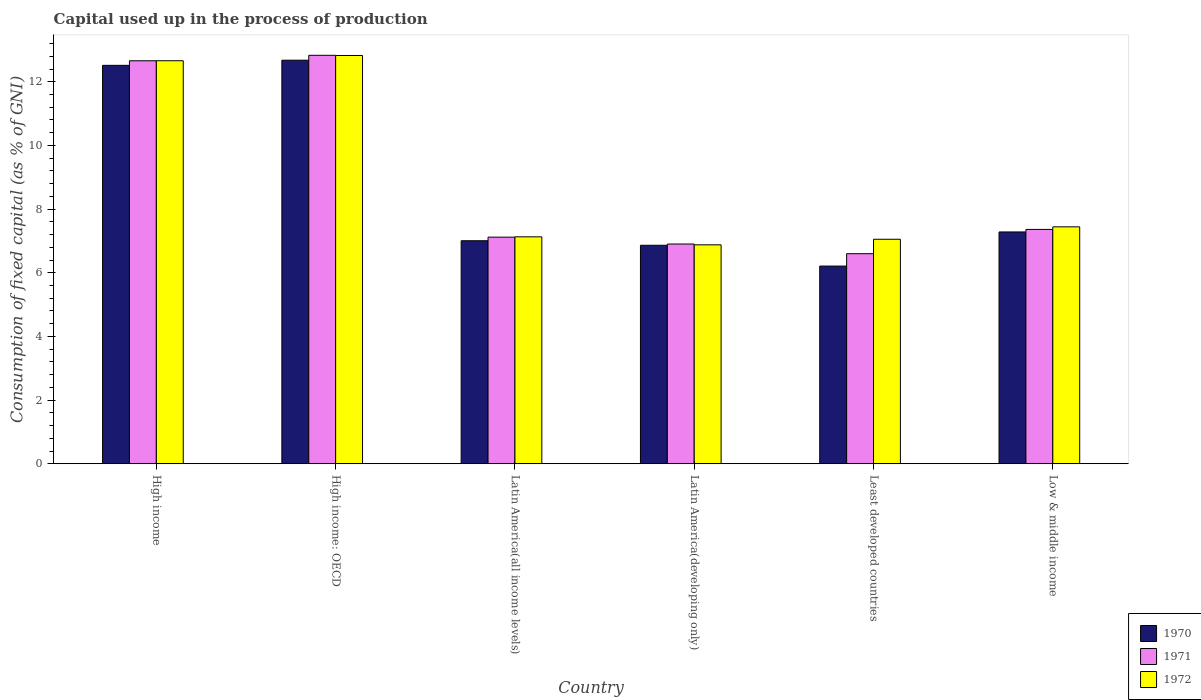How many groups of bars are there?
Keep it short and to the point. 6. Are the number of bars per tick equal to the number of legend labels?
Give a very brief answer. Yes. How many bars are there on the 2nd tick from the right?
Keep it short and to the point. 3. What is the label of the 1st group of bars from the left?
Provide a succinct answer. High income. In how many cases, is the number of bars for a given country not equal to the number of legend labels?
Your answer should be very brief. 0. What is the capital used up in the process of production in 1970 in High income?
Your response must be concise. 12.52. Across all countries, what is the maximum capital used up in the process of production in 1970?
Give a very brief answer. 12.68. Across all countries, what is the minimum capital used up in the process of production in 1970?
Ensure brevity in your answer.  6.21. In which country was the capital used up in the process of production in 1971 maximum?
Ensure brevity in your answer.  High income: OECD. In which country was the capital used up in the process of production in 1971 minimum?
Your answer should be very brief. Least developed countries. What is the total capital used up in the process of production in 1970 in the graph?
Your response must be concise. 52.56. What is the difference between the capital used up in the process of production in 1971 in Latin America(developing only) and that in Least developed countries?
Give a very brief answer. 0.3. What is the difference between the capital used up in the process of production in 1970 in Low & middle income and the capital used up in the process of production in 1972 in High income?
Your answer should be very brief. -5.38. What is the average capital used up in the process of production in 1970 per country?
Your response must be concise. 8.76. What is the difference between the capital used up in the process of production of/in 1971 and capital used up in the process of production of/in 1972 in Latin America(developing only)?
Your response must be concise. 0.03. What is the ratio of the capital used up in the process of production in 1972 in High income: OECD to that in Least developed countries?
Your response must be concise. 1.82. Is the capital used up in the process of production in 1972 in High income: OECD less than that in Least developed countries?
Offer a very short reply. No. Is the difference between the capital used up in the process of production in 1971 in High income and Latin America(all income levels) greater than the difference between the capital used up in the process of production in 1972 in High income and Latin America(all income levels)?
Provide a short and direct response. Yes. What is the difference between the highest and the second highest capital used up in the process of production in 1970?
Ensure brevity in your answer.  0.16. What is the difference between the highest and the lowest capital used up in the process of production in 1972?
Offer a terse response. 5.95. In how many countries, is the capital used up in the process of production in 1970 greater than the average capital used up in the process of production in 1970 taken over all countries?
Your answer should be compact. 2. What does the 1st bar from the left in High income represents?
Your answer should be compact. 1970. Are all the bars in the graph horizontal?
Provide a short and direct response. No. How many countries are there in the graph?
Your answer should be compact. 6. What is the difference between two consecutive major ticks on the Y-axis?
Your answer should be compact. 2. How many legend labels are there?
Offer a very short reply. 3. How are the legend labels stacked?
Your answer should be very brief. Vertical. What is the title of the graph?
Offer a terse response. Capital used up in the process of production. Does "1964" appear as one of the legend labels in the graph?
Ensure brevity in your answer.  No. What is the label or title of the Y-axis?
Make the answer very short. Consumption of fixed capital (as % of GNI). What is the Consumption of fixed capital (as % of GNI) of 1970 in High income?
Provide a succinct answer. 12.52. What is the Consumption of fixed capital (as % of GNI) of 1971 in High income?
Offer a very short reply. 12.66. What is the Consumption of fixed capital (as % of GNI) in 1972 in High income?
Provide a short and direct response. 12.66. What is the Consumption of fixed capital (as % of GNI) of 1970 in High income: OECD?
Keep it short and to the point. 12.68. What is the Consumption of fixed capital (as % of GNI) of 1971 in High income: OECD?
Offer a very short reply. 12.83. What is the Consumption of fixed capital (as % of GNI) in 1972 in High income: OECD?
Provide a short and direct response. 12.83. What is the Consumption of fixed capital (as % of GNI) of 1970 in Latin America(all income levels)?
Ensure brevity in your answer.  7.01. What is the Consumption of fixed capital (as % of GNI) of 1971 in Latin America(all income levels)?
Your answer should be compact. 7.12. What is the Consumption of fixed capital (as % of GNI) in 1972 in Latin America(all income levels)?
Offer a very short reply. 7.13. What is the Consumption of fixed capital (as % of GNI) in 1970 in Latin America(developing only)?
Provide a succinct answer. 6.86. What is the Consumption of fixed capital (as % of GNI) of 1971 in Latin America(developing only)?
Your answer should be compact. 6.9. What is the Consumption of fixed capital (as % of GNI) of 1972 in Latin America(developing only)?
Offer a terse response. 6.88. What is the Consumption of fixed capital (as % of GNI) of 1970 in Least developed countries?
Make the answer very short. 6.21. What is the Consumption of fixed capital (as % of GNI) of 1971 in Least developed countries?
Keep it short and to the point. 6.6. What is the Consumption of fixed capital (as % of GNI) in 1972 in Least developed countries?
Ensure brevity in your answer.  7.05. What is the Consumption of fixed capital (as % of GNI) in 1970 in Low & middle income?
Offer a very short reply. 7.28. What is the Consumption of fixed capital (as % of GNI) in 1971 in Low & middle income?
Your answer should be compact. 7.36. What is the Consumption of fixed capital (as % of GNI) in 1972 in Low & middle income?
Provide a succinct answer. 7.44. Across all countries, what is the maximum Consumption of fixed capital (as % of GNI) of 1970?
Offer a terse response. 12.68. Across all countries, what is the maximum Consumption of fixed capital (as % of GNI) in 1971?
Offer a terse response. 12.83. Across all countries, what is the maximum Consumption of fixed capital (as % of GNI) of 1972?
Make the answer very short. 12.83. Across all countries, what is the minimum Consumption of fixed capital (as % of GNI) of 1970?
Your answer should be compact. 6.21. Across all countries, what is the minimum Consumption of fixed capital (as % of GNI) of 1971?
Offer a very short reply. 6.6. Across all countries, what is the minimum Consumption of fixed capital (as % of GNI) in 1972?
Make the answer very short. 6.88. What is the total Consumption of fixed capital (as % of GNI) in 1970 in the graph?
Offer a terse response. 52.56. What is the total Consumption of fixed capital (as % of GNI) in 1971 in the graph?
Make the answer very short. 53.47. What is the total Consumption of fixed capital (as % of GNI) in 1972 in the graph?
Offer a very short reply. 53.99. What is the difference between the Consumption of fixed capital (as % of GNI) of 1970 in High income and that in High income: OECD?
Offer a very short reply. -0.16. What is the difference between the Consumption of fixed capital (as % of GNI) in 1971 in High income and that in High income: OECD?
Your answer should be compact. -0.17. What is the difference between the Consumption of fixed capital (as % of GNI) of 1972 in High income and that in High income: OECD?
Provide a succinct answer. -0.17. What is the difference between the Consumption of fixed capital (as % of GNI) of 1970 in High income and that in Latin America(all income levels)?
Your answer should be very brief. 5.51. What is the difference between the Consumption of fixed capital (as % of GNI) in 1971 in High income and that in Latin America(all income levels)?
Make the answer very short. 5.54. What is the difference between the Consumption of fixed capital (as % of GNI) of 1972 in High income and that in Latin America(all income levels)?
Ensure brevity in your answer.  5.53. What is the difference between the Consumption of fixed capital (as % of GNI) in 1970 in High income and that in Latin America(developing only)?
Your answer should be very brief. 5.65. What is the difference between the Consumption of fixed capital (as % of GNI) of 1971 in High income and that in Latin America(developing only)?
Keep it short and to the point. 5.76. What is the difference between the Consumption of fixed capital (as % of GNI) of 1972 in High income and that in Latin America(developing only)?
Your answer should be very brief. 5.78. What is the difference between the Consumption of fixed capital (as % of GNI) in 1970 in High income and that in Least developed countries?
Give a very brief answer. 6.31. What is the difference between the Consumption of fixed capital (as % of GNI) in 1971 in High income and that in Least developed countries?
Offer a terse response. 6.06. What is the difference between the Consumption of fixed capital (as % of GNI) in 1972 in High income and that in Least developed countries?
Give a very brief answer. 5.61. What is the difference between the Consumption of fixed capital (as % of GNI) of 1970 in High income and that in Low & middle income?
Make the answer very short. 5.23. What is the difference between the Consumption of fixed capital (as % of GNI) of 1971 in High income and that in Low & middle income?
Offer a terse response. 5.3. What is the difference between the Consumption of fixed capital (as % of GNI) of 1972 in High income and that in Low & middle income?
Your response must be concise. 5.22. What is the difference between the Consumption of fixed capital (as % of GNI) in 1970 in High income: OECD and that in Latin America(all income levels)?
Your answer should be compact. 5.67. What is the difference between the Consumption of fixed capital (as % of GNI) in 1971 in High income: OECD and that in Latin America(all income levels)?
Your answer should be very brief. 5.71. What is the difference between the Consumption of fixed capital (as % of GNI) in 1972 in High income: OECD and that in Latin America(all income levels)?
Your answer should be compact. 5.7. What is the difference between the Consumption of fixed capital (as % of GNI) of 1970 in High income: OECD and that in Latin America(developing only)?
Offer a very short reply. 5.81. What is the difference between the Consumption of fixed capital (as % of GNI) of 1971 in High income: OECD and that in Latin America(developing only)?
Make the answer very short. 5.93. What is the difference between the Consumption of fixed capital (as % of GNI) of 1972 in High income: OECD and that in Latin America(developing only)?
Your response must be concise. 5.95. What is the difference between the Consumption of fixed capital (as % of GNI) in 1970 in High income: OECD and that in Least developed countries?
Provide a short and direct response. 6.47. What is the difference between the Consumption of fixed capital (as % of GNI) in 1971 in High income: OECD and that in Least developed countries?
Your answer should be very brief. 6.23. What is the difference between the Consumption of fixed capital (as % of GNI) of 1972 in High income: OECD and that in Least developed countries?
Your answer should be compact. 5.77. What is the difference between the Consumption of fixed capital (as % of GNI) of 1970 in High income: OECD and that in Low & middle income?
Offer a very short reply. 5.4. What is the difference between the Consumption of fixed capital (as % of GNI) in 1971 in High income: OECD and that in Low & middle income?
Provide a short and direct response. 5.47. What is the difference between the Consumption of fixed capital (as % of GNI) of 1972 in High income: OECD and that in Low & middle income?
Your response must be concise. 5.38. What is the difference between the Consumption of fixed capital (as % of GNI) in 1970 in Latin America(all income levels) and that in Latin America(developing only)?
Your answer should be very brief. 0.14. What is the difference between the Consumption of fixed capital (as % of GNI) in 1971 in Latin America(all income levels) and that in Latin America(developing only)?
Provide a succinct answer. 0.22. What is the difference between the Consumption of fixed capital (as % of GNI) in 1972 in Latin America(all income levels) and that in Latin America(developing only)?
Your answer should be very brief. 0.25. What is the difference between the Consumption of fixed capital (as % of GNI) of 1970 in Latin America(all income levels) and that in Least developed countries?
Give a very brief answer. 0.8. What is the difference between the Consumption of fixed capital (as % of GNI) of 1971 in Latin America(all income levels) and that in Least developed countries?
Your answer should be very brief. 0.52. What is the difference between the Consumption of fixed capital (as % of GNI) in 1972 in Latin America(all income levels) and that in Least developed countries?
Your answer should be compact. 0.08. What is the difference between the Consumption of fixed capital (as % of GNI) in 1970 in Latin America(all income levels) and that in Low & middle income?
Provide a short and direct response. -0.28. What is the difference between the Consumption of fixed capital (as % of GNI) in 1971 in Latin America(all income levels) and that in Low & middle income?
Offer a terse response. -0.24. What is the difference between the Consumption of fixed capital (as % of GNI) in 1972 in Latin America(all income levels) and that in Low & middle income?
Offer a very short reply. -0.31. What is the difference between the Consumption of fixed capital (as % of GNI) in 1970 in Latin America(developing only) and that in Least developed countries?
Provide a short and direct response. 0.65. What is the difference between the Consumption of fixed capital (as % of GNI) in 1971 in Latin America(developing only) and that in Least developed countries?
Give a very brief answer. 0.3. What is the difference between the Consumption of fixed capital (as % of GNI) in 1972 in Latin America(developing only) and that in Least developed countries?
Ensure brevity in your answer.  -0.18. What is the difference between the Consumption of fixed capital (as % of GNI) of 1970 in Latin America(developing only) and that in Low & middle income?
Offer a very short reply. -0.42. What is the difference between the Consumption of fixed capital (as % of GNI) of 1971 in Latin America(developing only) and that in Low & middle income?
Give a very brief answer. -0.46. What is the difference between the Consumption of fixed capital (as % of GNI) in 1972 in Latin America(developing only) and that in Low & middle income?
Ensure brevity in your answer.  -0.57. What is the difference between the Consumption of fixed capital (as % of GNI) in 1970 in Least developed countries and that in Low & middle income?
Keep it short and to the point. -1.07. What is the difference between the Consumption of fixed capital (as % of GNI) in 1971 in Least developed countries and that in Low & middle income?
Keep it short and to the point. -0.76. What is the difference between the Consumption of fixed capital (as % of GNI) of 1972 in Least developed countries and that in Low & middle income?
Keep it short and to the point. -0.39. What is the difference between the Consumption of fixed capital (as % of GNI) of 1970 in High income and the Consumption of fixed capital (as % of GNI) of 1971 in High income: OECD?
Your response must be concise. -0.32. What is the difference between the Consumption of fixed capital (as % of GNI) of 1970 in High income and the Consumption of fixed capital (as % of GNI) of 1972 in High income: OECD?
Make the answer very short. -0.31. What is the difference between the Consumption of fixed capital (as % of GNI) in 1971 in High income and the Consumption of fixed capital (as % of GNI) in 1972 in High income: OECD?
Give a very brief answer. -0.17. What is the difference between the Consumption of fixed capital (as % of GNI) of 1970 in High income and the Consumption of fixed capital (as % of GNI) of 1971 in Latin America(all income levels)?
Keep it short and to the point. 5.4. What is the difference between the Consumption of fixed capital (as % of GNI) of 1970 in High income and the Consumption of fixed capital (as % of GNI) of 1972 in Latin America(all income levels)?
Your answer should be compact. 5.39. What is the difference between the Consumption of fixed capital (as % of GNI) in 1971 in High income and the Consumption of fixed capital (as % of GNI) in 1972 in Latin America(all income levels)?
Your response must be concise. 5.53. What is the difference between the Consumption of fixed capital (as % of GNI) in 1970 in High income and the Consumption of fixed capital (as % of GNI) in 1971 in Latin America(developing only)?
Make the answer very short. 5.61. What is the difference between the Consumption of fixed capital (as % of GNI) in 1970 in High income and the Consumption of fixed capital (as % of GNI) in 1972 in Latin America(developing only)?
Provide a short and direct response. 5.64. What is the difference between the Consumption of fixed capital (as % of GNI) of 1971 in High income and the Consumption of fixed capital (as % of GNI) of 1972 in Latin America(developing only)?
Provide a succinct answer. 5.78. What is the difference between the Consumption of fixed capital (as % of GNI) in 1970 in High income and the Consumption of fixed capital (as % of GNI) in 1971 in Least developed countries?
Provide a short and direct response. 5.92. What is the difference between the Consumption of fixed capital (as % of GNI) in 1970 in High income and the Consumption of fixed capital (as % of GNI) in 1972 in Least developed countries?
Your answer should be compact. 5.46. What is the difference between the Consumption of fixed capital (as % of GNI) of 1971 in High income and the Consumption of fixed capital (as % of GNI) of 1972 in Least developed countries?
Provide a short and direct response. 5.61. What is the difference between the Consumption of fixed capital (as % of GNI) in 1970 in High income and the Consumption of fixed capital (as % of GNI) in 1971 in Low & middle income?
Your answer should be very brief. 5.15. What is the difference between the Consumption of fixed capital (as % of GNI) of 1970 in High income and the Consumption of fixed capital (as % of GNI) of 1972 in Low & middle income?
Your response must be concise. 5.07. What is the difference between the Consumption of fixed capital (as % of GNI) in 1971 in High income and the Consumption of fixed capital (as % of GNI) in 1972 in Low & middle income?
Make the answer very short. 5.22. What is the difference between the Consumption of fixed capital (as % of GNI) in 1970 in High income: OECD and the Consumption of fixed capital (as % of GNI) in 1971 in Latin America(all income levels)?
Keep it short and to the point. 5.56. What is the difference between the Consumption of fixed capital (as % of GNI) of 1970 in High income: OECD and the Consumption of fixed capital (as % of GNI) of 1972 in Latin America(all income levels)?
Give a very brief answer. 5.55. What is the difference between the Consumption of fixed capital (as % of GNI) in 1971 in High income: OECD and the Consumption of fixed capital (as % of GNI) in 1972 in Latin America(all income levels)?
Offer a very short reply. 5.7. What is the difference between the Consumption of fixed capital (as % of GNI) in 1970 in High income: OECD and the Consumption of fixed capital (as % of GNI) in 1971 in Latin America(developing only)?
Ensure brevity in your answer.  5.78. What is the difference between the Consumption of fixed capital (as % of GNI) of 1970 in High income: OECD and the Consumption of fixed capital (as % of GNI) of 1972 in Latin America(developing only)?
Your answer should be very brief. 5.8. What is the difference between the Consumption of fixed capital (as % of GNI) of 1971 in High income: OECD and the Consumption of fixed capital (as % of GNI) of 1972 in Latin America(developing only)?
Your answer should be very brief. 5.95. What is the difference between the Consumption of fixed capital (as % of GNI) of 1970 in High income: OECD and the Consumption of fixed capital (as % of GNI) of 1971 in Least developed countries?
Offer a terse response. 6.08. What is the difference between the Consumption of fixed capital (as % of GNI) in 1970 in High income: OECD and the Consumption of fixed capital (as % of GNI) in 1972 in Least developed countries?
Provide a succinct answer. 5.63. What is the difference between the Consumption of fixed capital (as % of GNI) in 1971 in High income: OECD and the Consumption of fixed capital (as % of GNI) in 1972 in Least developed countries?
Offer a very short reply. 5.78. What is the difference between the Consumption of fixed capital (as % of GNI) in 1970 in High income: OECD and the Consumption of fixed capital (as % of GNI) in 1971 in Low & middle income?
Give a very brief answer. 5.32. What is the difference between the Consumption of fixed capital (as % of GNI) in 1970 in High income: OECD and the Consumption of fixed capital (as % of GNI) in 1972 in Low & middle income?
Make the answer very short. 5.24. What is the difference between the Consumption of fixed capital (as % of GNI) in 1971 in High income: OECD and the Consumption of fixed capital (as % of GNI) in 1972 in Low & middle income?
Provide a short and direct response. 5.39. What is the difference between the Consumption of fixed capital (as % of GNI) of 1970 in Latin America(all income levels) and the Consumption of fixed capital (as % of GNI) of 1971 in Latin America(developing only)?
Your answer should be compact. 0.1. What is the difference between the Consumption of fixed capital (as % of GNI) of 1970 in Latin America(all income levels) and the Consumption of fixed capital (as % of GNI) of 1972 in Latin America(developing only)?
Offer a very short reply. 0.13. What is the difference between the Consumption of fixed capital (as % of GNI) of 1971 in Latin America(all income levels) and the Consumption of fixed capital (as % of GNI) of 1972 in Latin America(developing only)?
Provide a short and direct response. 0.24. What is the difference between the Consumption of fixed capital (as % of GNI) of 1970 in Latin America(all income levels) and the Consumption of fixed capital (as % of GNI) of 1971 in Least developed countries?
Your response must be concise. 0.41. What is the difference between the Consumption of fixed capital (as % of GNI) of 1970 in Latin America(all income levels) and the Consumption of fixed capital (as % of GNI) of 1972 in Least developed countries?
Your answer should be very brief. -0.05. What is the difference between the Consumption of fixed capital (as % of GNI) of 1971 in Latin America(all income levels) and the Consumption of fixed capital (as % of GNI) of 1972 in Least developed countries?
Offer a terse response. 0.07. What is the difference between the Consumption of fixed capital (as % of GNI) of 1970 in Latin America(all income levels) and the Consumption of fixed capital (as % of GNI) of 1971 in Low & middle income?
Provide a succinct answer. -0.36. What is the difference between the Consumption of fixed capital (as % of GNI) of 1970 in Latin America(all income levels) and the Consumption of fixed capital (as % of GNI) of 1972 in Low & middle income?
Your response must be concise. -0.44. What is the difference between the Consumption of fixed capital (as % of GNI) in 1971 in Latin America(all income levels) and the Consumption of fixed capital (as % of GNI) in 1972 in Low & middle income?
Offer a very short reply. -0.32. What is the difference between the Consumption of fixed capital (as % of GNI) in 1970 in Latin America(developing only) and the Consumption of fixed capital (as % of GNI) in 1971 in Least developed countries?
Your answer should be compact. 0.26. What is the difference between the Consumption of fixed capital (as % of GNI) in 1970 in Latin America(developing only) and the Consumption of fixed capital (as % of GNI) in 1972 in Least developed countries?
Your answer should be very brief. -0.19. What is the difference between the Consumption of fixed capital (as % of GNI) of 1971 in Latin America(developing only) and the Consumption of fixed capital (as % of GNI) of 1972 in Least developed countries?
Your answer should be compact. -0.15. What is the difference between the Consumption of fixed capital (as % of GNI) of 1970 in Latin America(developing only) and the Consumption of fixed capital (as % of GNI) of 1971 in Low & middle income?
Ensure brevity in your answer.  -0.5. What is the difference between the Consumption of fixed capital (as % of GNI) of 1970 in Latin America(developing only) and the Consumption of fixed capital (as % of GNI) of 1972 in Low & middle income?
Offer a very short reply. -0.58. What is the difference between the Consumption of fixed capital (as % of GNI) of 1971 in Latin America(developing only) and the Consumption of fixed capital (as % of GNI) of 1972 in Low & middle income?
Offer a terse response. -0.54. What is the difference between the Consumption of fixed capital (as % of GNI) of 1970 in Least developed countries and the Consumption of fixed capital (as % of GNI) of 1971 in Low & middle income?
Offer a terse response. -1.15. What is the difference between the Consumption of fixed capital (as % of GNI) of 1970 in Least developed countries and the Consumption of fixed capital (as % of GNI) of 1972 in Low & middle income?
Ensure brevity in your answer.  -1.23. What is the difference between the Consumption of fixed capital (as % of GNI) in 1971 in Least developed countries and the Consumption of fixed capital (as % of GNI) in 1972 in Low & middle income?
Your response must be concise. -0.84. What is the average Consumption of fixed capital (as % of GNI) in 1970 per country?
Your answer should be very brief. 8.76. What is the average Consumption of fixed capital (as % of GNI) in 1971 per country?
Offer a terse response. 8.91. What is the average Consumption of fixed capital (as % of GNI) of 1972 per country?
Ensure brevity in your answer.  9. What is the difference between the Consumption of fixed capital (as % of GNI) of 1970 and Consumption of fixed capital (as % of GNI) of 1971 in High income?
Provide a short and direct response. -0.14. What is the difference between the Consumption of fixed capital (as % of GNI) in 1970 and Consumption of fixed capital (as % of GNI) in 1972 in High income?
Your answer should be compact. -0.14. What is the difference between the Consumption of fixed capital (as % of GNI) in 1971 and Consumption of fixed capital (as % of GNI) in 1972 in High income?
Keep it short and to the point. -0. What is the difference between the Consumption of fixed capital (as % of GNI) of 1970 and Consumption of fixed capital (as % of GNI) of 1971 in High income: OECD?
Ensure brevity in your answer.  -0.15. What is the difference between the Consumption of fixed capital (as % of GNI) of 1970 and Consumption of fixed capital (as % of GNI) of 1972 in High income: OECD?
Provide a succinct answer. -0.15. What is the difference between the Consumption of fixed capital (as % of GNI) in 1971 and Consumption of fixed capital (as % of GNI) in 1972 in High income: OECD?
Keep it short and to the point. 0.01. What is the difference between the Consumption of fixed capital (as % of GNI) in 1970 and Consumption of fixed capital (as % of GNI) in 1971 in Latin America(all income levels)?
Your answer should be compact. -0.11. What is the difference between the Consumption of fixed capital (as % of GNI) of 1970 and Consumption of fixed capital (as % of GNI) of 1972 in Latin America(all income levels)?
Provide a succinct answer. -0.12. What is the difference between the Consumption of fixed capital (as % of GNI) of 1971 and Consumption of fixed capital (as % of GNI) of 1972 in Latin America(all income levels)?
Provide a short and direct response. -0.01. What is the difference between the Consumption of fixed capital (as % of GNI) in 1970 and Consumption of fixed capital (as % of GNI) in 1971 in Latin America(developing only)?
Make the answer very short. -0.04. What is the difference between the Consumption of fixed capital (as % of GNI) of 1970 and Consumption of fixed capital (as % of GNI) of 1972 in Latin America(developing only)?
Your answer should be very brief. -0.01. What is the difference between the Consumption of fixed capital (as % of GNI) of 1971 and Consumption of fixed capital (as % of GNI) of 1972 in Latin America(developing only)?
Provide a short and direct response. 0.03. What is the difference between the Consumption of fixed capital (as % of GNI) in 1970 and Consumption of fixed capital (as % of GNI) in 1971 in Least developed countries?
Offer a terse response. -0.39. What is the difference between the Consumption of fixed capital (as % of GNI) of 1970 and Consumption of fixed capital (as % of GNI) of 1972 in Least developed countries?
Your answer should be very brief. -0.84. What is the difference between the Consumption of fixed capital (as % of GNI) of 1971 and Consumption of fixed capital (as % of GNI) of 1972 in Least developed countries?
Your answer should be very brief. -0.45. What is the difference between the Consumption of fixed capital (as % of GNI) of 1970 and Consumption of fixed capital (as % of GNI) of 1971 in Low & middle income?
Offer a terse response. -0.08. What is the difference between the Consumption of fixed capital (as % of GNI) in 1970 and Consumption of fixed capital (as % of GNI) in 1972 in Low & middle income?
Provide a succinct answer. -0.16. What is the difference between the Consumption of fixed capital (as % of GNI) in 1971 and Consumption of fixed capital (as % of GNI) in 1972 in Low & middle income?
Your response must be concise. -0.08. What is the ratio of the Consumption of fixed capital (as % of GNI) in 1970 in High income to that in High income: OECD?
Keep it short and to the point. 0.99. What is the ratio of the Consumption of fixed capital (as % of GNI) of 1971 in High income to that in High income: OECD?
Your answer should be compact. 0.99. What is the ratio of the Consumption of fixed capital (as % of GNI) of 1972 in High income to that in High income: OECD?
Ensure brevity in your answer.  0.99. What is the ratio of the Consumption of fixed capital (as % of GNI) in 1970 in High income to that in Latin America(all income levels)?
Offer a very short reply. 1.79. What is the ratio of the Consumption of fixed capital (as % of GNI) in 1971 in High income to that in Latin America(all income levels)?
Keep it short and to the point. 1.78. What is the ratio of the Consumption of fixed capital (as % of GNI) in 1972 in High income to that in Latin America(all income levels)?
Give a very brief answer. 1.78. What is the ratio of the Consumption of fixed capital (as % of GNI) in 1970 in High income to that in Latin America(developing only)?
Offer a very short reply. 1.82. What is the ratio of the Consumption of fixed capital (as % of GNI) of 1971 in High income to that in Latin America(developing only)?
Provide a short and direct response. 1.83. What is the ratio of the Consumption of fixed capital (as % of GNI) in 1972 in High income to that in Latin America(developing only)?
Offer a very short reply. 1.84. What is the ratio of the Consumption of fixed capital (as % of GNI) in 1970 in High income to that in Least developed countries?
Offer a very short reply. 2.02. What is the ratio of the Consumption of fixed capital (as % of GNI) of 1971 in High income to that in Least developed countries?
Give a very brief answer. 1.92. What is the ratio of the Consumption of fixed capital (as % of GNI) of 1972 in High income to that in Least developed countries?
Provide a short and direct response. 1.8. What is the ratio of the Consumption of fixed capital (as % of GNI) of 1970 in High income to that in Low & middle income?
Ensure brevity in your answer.  1.72. What is the ratio of the Consumption of fixed capital (as % of GNI) of 1971 in High income to that in Low & middle income?
Provide a short and direct response. 1.72. What is the ratio of the Consumption of fixed capital (as % of GNI) in 1972 in High income to that in Low & middle income?
Offer a very short reply. 1.7. What is the ratio of the Consumption of fixed capital (as % of GNI) in 1970 in High income: OECD to that in Latin America(all income levels)?
Your answer should be very brief. 1.81. What is the ratio of the Consumption of fixed capital (as % of GNI) of 1971 in High income: OECD to that in Latin America(all income levels)?
Keep it short and to the point. 1.8. What is the ratio of the Consumption of fixed capital (as % of GNI) of 1972 in High income: OECD to that in Latin America(all income levels)?
Offer a very short reply. 1.8. What is the ratio of the Consumption of fixed capital (as % of GNI) of 1970 in High income: OECD to that in Latin America(developing only)?
Keep it short and to the point. 1.85. What is the ratio of the Consumption of fixed capital (as % of GNI) in 1971 in High income: OECD to that in Latin America(developing only)?
Offer a very short reply. 1.86. What is the ratio of the Consumption of fixed capital (as % of GNI) of 1972 in High income: OECD to that in Latin America(developing only)?
Your answer should be very brief. 1.86. What is the ratio of the Consumption of fixed capital (as % of GNI) in 1970 in High income: OECD to that in Least developed countries?
Your response must be concise. 2.04. What is the ratio of the Consumption of fixed capital (as % of GNI) of 1971 in High income: OECD to that in Least developed countries?
Provide a succinct answer. 1.94. What is the ratio of the Consumption of fixed capital (as % of GNI) in 1972 in High income: OECD to that in Least developed countries?
Give a very brief answer. 1.82. What is the ratio of the Consumption of fixed capital (as % of GNI) in 1970 in High income: OECD to that in Low & middle income?
Your response must be concise. 1.74. What is the ratio of the Consumption of fixed capital (as % of GNI) of 1971 in High income: OECD to that in Low & middle income?
Your response must be concise. 1.74. What is the ratio of the Consumption of fixed capital (as % of GNI) in 1972 in High income: OECD to that in Low & middle income?
Provide a short and direct response. 1.72. What is the ratio of the Consumption of fixed capital (as % of GNI) of 1970 in Latin America(all income levels) to that in Latin America(developing only)?
Provide a short and direct response. 1.02. What is the ratio of the Consumption of fixed capital (as % of GNI) of 1971 in Latin America(all income levels) to that in Latin America(developing only)?
Provide a succinct answer. 1.03. What is the ratio of the Consumption of fixed capital (as % of GNI) of 1972 in Latin America(all income levels) to that in Latin America(developing only)?
Keep it short and to the point. 1.04. What is the ratio of the Consumption of fixed capital (as % of GNI) of 1970 in Latin America(all income levels) to that in Least developed countries?
Offer a terse response. 1.13. What is the ratio of the Consumption of fixed capital (as % of GNI) in 1971 in Latin America(all income levels) to that in Least developed countries?
Give a very brief answer. 1.08. What is the ratio of the Consumption of fixed capital (as % of GNI) of 1972 in Latin America(all income levels) to that in Least developed countries?
Provide a succinct answer. 1.01. What is the ratio of the Consumption of fixed capital (as % of GNI) of 1971 in Latin America(all income levels) to that in Low & middle income?
Your response must be concise. 0.97. What is the ratio of the Consumption of fixed capital (as % of GNI) in 1972 in Latin America(all income levels) to that in Low & middle income?
Give a very brief answer. 0.96. What is the ratio of the Consumption of fixed capital (as % of GNI) of 1970 in Latin America(developing only) to that in Least developed countries?
Ensure brevity in your answer.  1.11. What is the ratio of the Consumption of fixed capital (as % of GNI) in 1971 in Latin America(developing only) to that in Least developed countries?
Provide a short and direct response. 1.05. What is the ratio of the Consumption of fixed capital (as % of GNI) in 1972 in Latin America(developing only) to that in Least developed countries?
Provide a succinct answer. 0.98. What is the ratio of the Consumption of fixed capital (as % of GNI) of 1970 in Latin America(developing only) to that in Low & middle income?
Your answer should be compact. 0.94. What is the ratio of the Consumption of fixed capital (as % of GNI) in 1971 in Latin America(developing only) to that in Low & middle income?
Offer a terse response. 0.94. What is the ratio of the Consumption of fixed capital (as % of GNI) in 1972 in Latin America(developing only) to that in Low & middle income?
Ensure brevity in your answer.  0.92. What is the ratio of the Consumption of fixed capital (as % of GNI) of 1970 in Least developed countries to that in Low & middle income?
Offer a terse response. 0.85. What is the ratio of the Consumption of fixed capital (as % of GNI) of 1971 in Least developed countries to that in Low & middle income?
Your answer should be very brief. 0.9. What is the ratio of the Consumption of fixed capital (as % of GNI) in 1972 in Least developed countries to that in Low & middle income?
Make the answer very short. 0.95. What is the difference between the highest and the second highest Consumption of fixed capital (as % of GNI) in 1970?
Offer a terse response. 0.16. What is the difference between the highest and the second highest Consumption of fixed capital (as % of GNI) of 1971?
Your response must be concise. 0.17. What is the difference between the highest and the second highest Consumption of fixed capital (as % of GNI) in 1972?
Offer a very short reply. 0.17. What is the difference between the highest and the lowest Consumption of fixed capital (as % of GNI) of 1970?
Give a very brief answer. 6.47. What is the difference between the highest and the lowest Consumption of fixed capital (as % of GNI) in 1971?
Offer a very short reply. 6.23. What is the difference between the highest and the lowest Consumption of fixed capital (as % of GNI) of 1972?
Your answer should be compact. 5.95. 